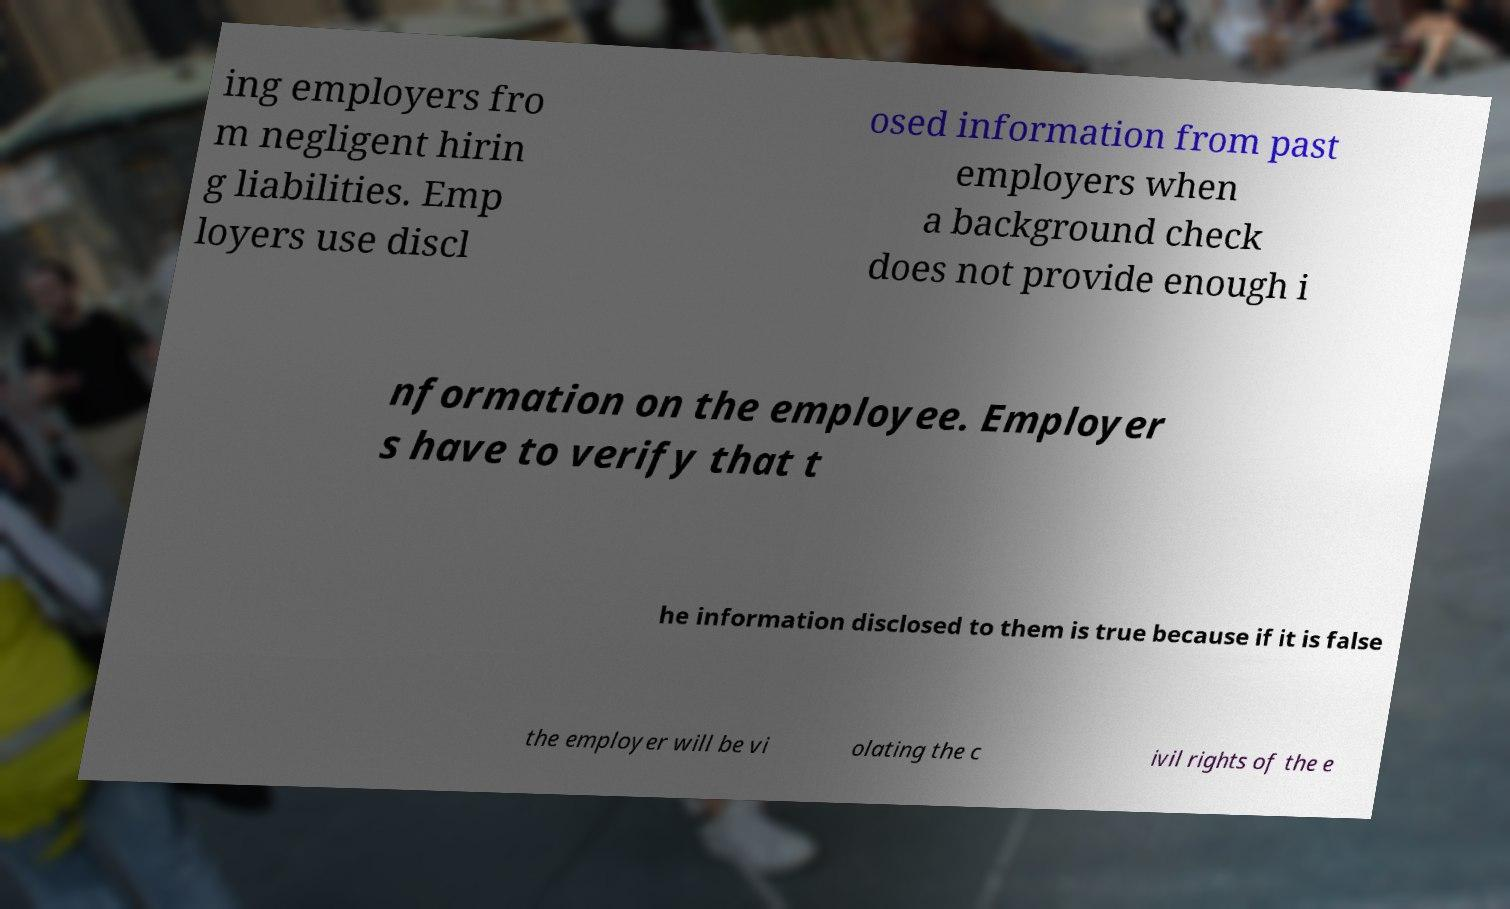Please read and relay the text visible in this image. What does it say? ing employers fro m negligent hirin g liabilities. Emp loyers use discl osed information from past employers when a background check does not provide enough i nformation on the employee. Employer s have to verify that t he information disclosed to them is true because if it is false the employer will be vi olating the c ivil rights of the e 